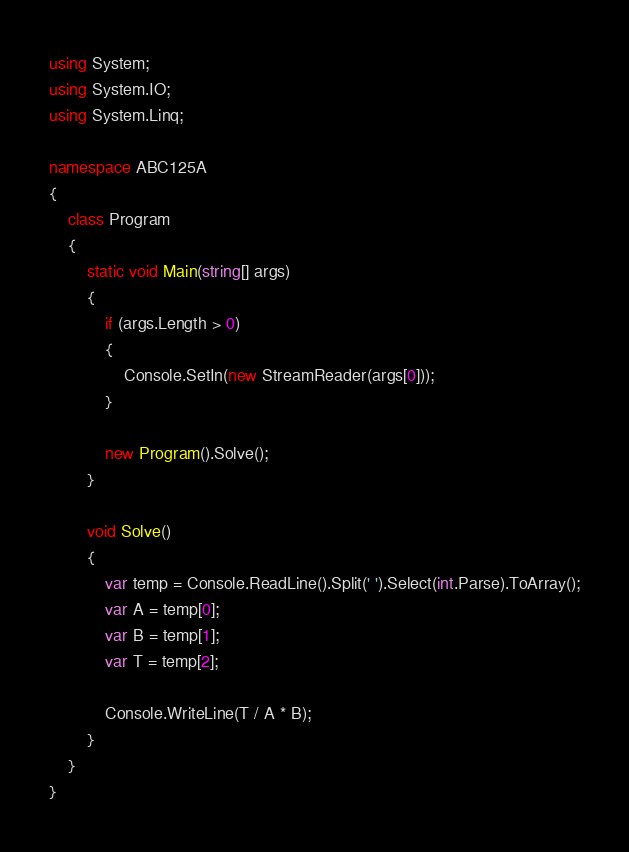Convert code to text. <code><loc_0><loc_0><loc_500><loc_500><_C#_>using System;
using System.IO;
using System.Linq;

namespace ABC125A
{
    class Program
    {
        static void Main(string[] args)
        {
            if (args.Length > 0)
            {
                Console.SetIn(new StreamReader(args[0]));
            }

            new Program().Solve();
        }

        void Solve()
        {
            var temp = Console.ReadLine().Split(' ').Select(int.Parse).ToArray();
            var A = temp[0];
            var B = temp[1];
            var T = temp[2];

            Console.WriteLine(T / A * B);
        }
    }
}
</code> 